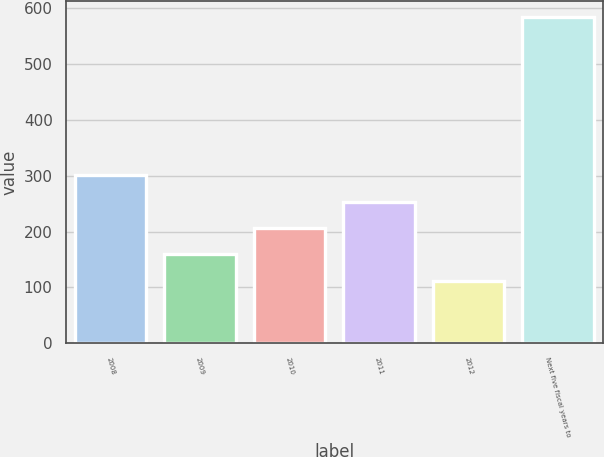Convert chart to OTSL. <chart><loc_0><loc_0><loc_500><loc_500><bar_chart><fcel>2008<fcel>2009<fcel>2010<fcel>2011<fcel>2012<fcel>Next five fiscal years to<nl><fcel>300.8<fcel>159.2<fcel>206.4<fcel>253.6<fcel>112<fcel>584<nl></chart> 